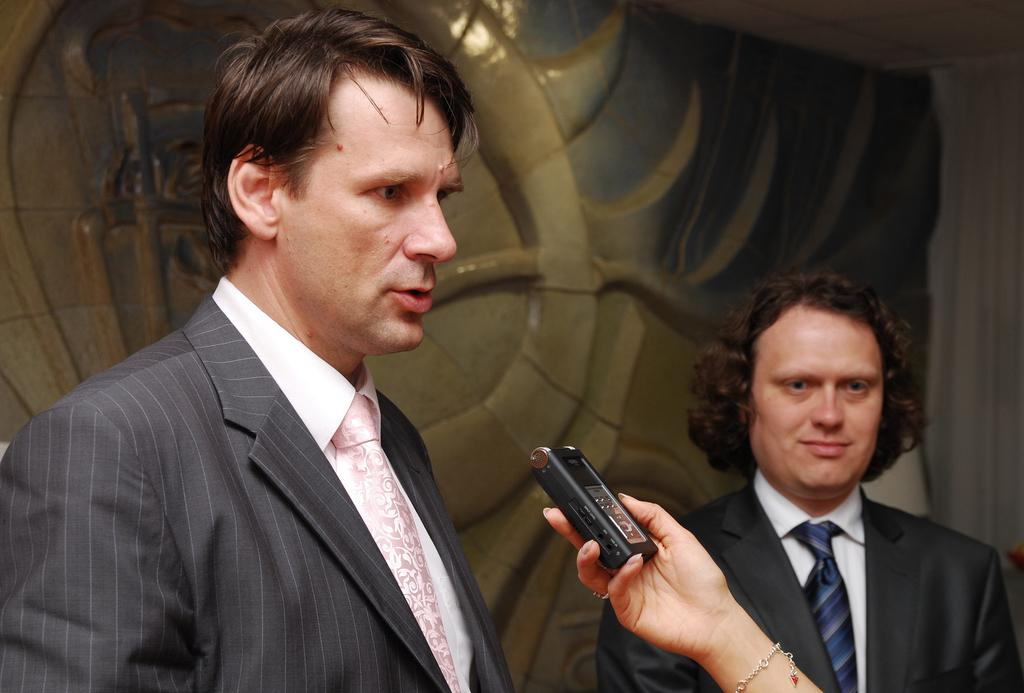How many people are in the room in the image? There are two persons standing in the room. Can you describe what one of the persons is doing? There is a person's hand holding an object in the image. What can be seen on the wall in the background? There is a wall with some design in the background. What type of argument can be heard between the bushes in the image? There are no bushes present in the image, so it is not possible to determine if there is an argument or not. 